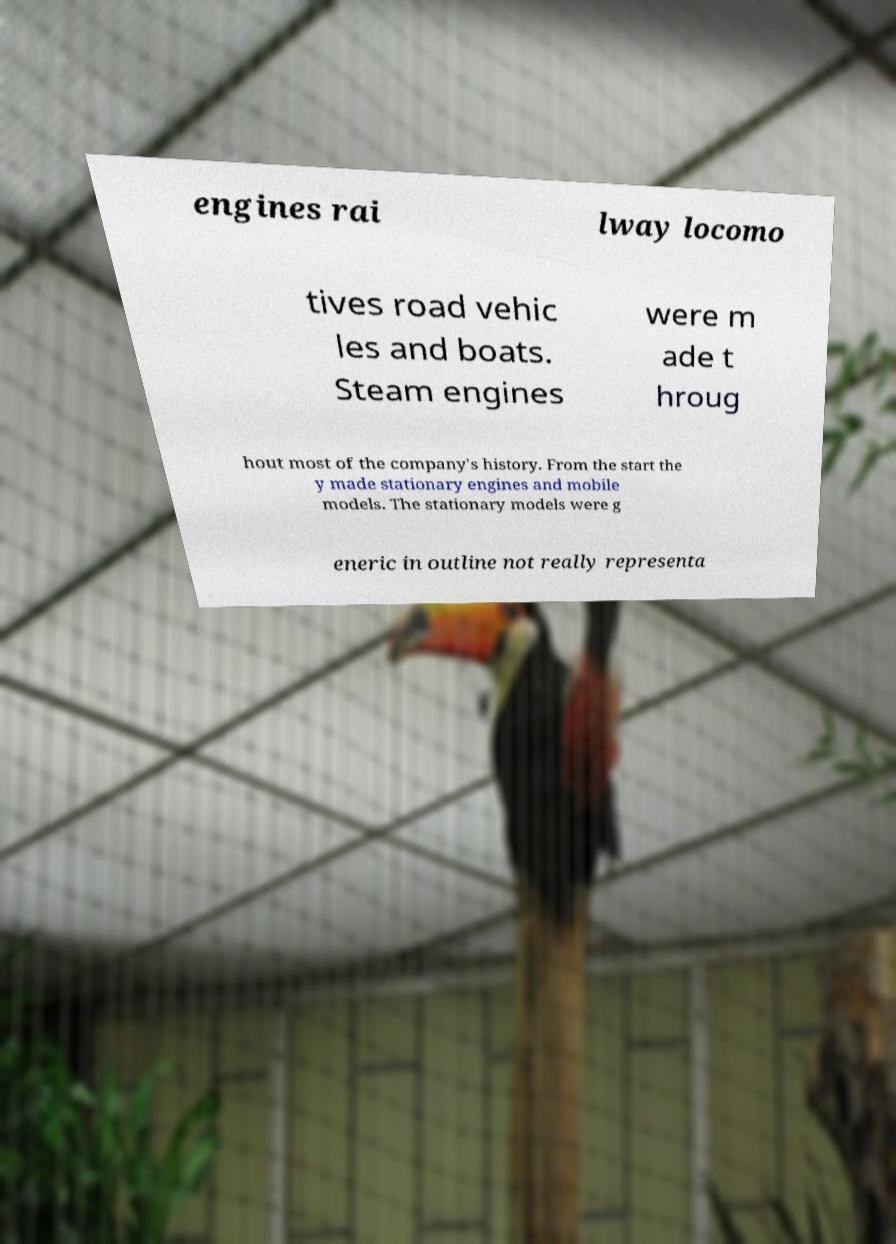Can you read and provide the text displayed in the image?This photo seems to have some interesting text. Can you extract and type it out for me? engines rai lway locomo tives road vehic les and boats. Steam engines were m ade t hroug hout most of the company's history. From the start the y made stationary engines and mobile models. The stationary models were g eneric in outline not really representa 